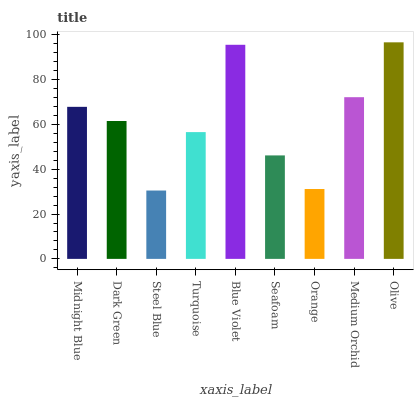Is Steel Blue the minimum?
Answer yes or no. Yes. Is Olive the maximum?
Answer yes or no. Yes. Is Dark Green the minimum?
Answer yes or no. No. Is Dark Green the maximum?
Answer yes or no. No. Is Midnight Blue greater than Dark Green?
Answer yes or no. Yes. Is Dark Green less than Midnight Blue?
Answer yes or no. Yes. Is Dark Green greater than Midnight Blue?
Answer yes or no. No. Is Midnight Blue less than Dark Green?
Answer yes or no. No. Is Dark Green the high median?
Answer yes or no. Yes. Is Dark Green the low median?
Answer yes or no. Yes. Is Steel Blue the high median?
Answer yes or no. No. Is Blue Violet the low median?
Answer yes or no. No. 